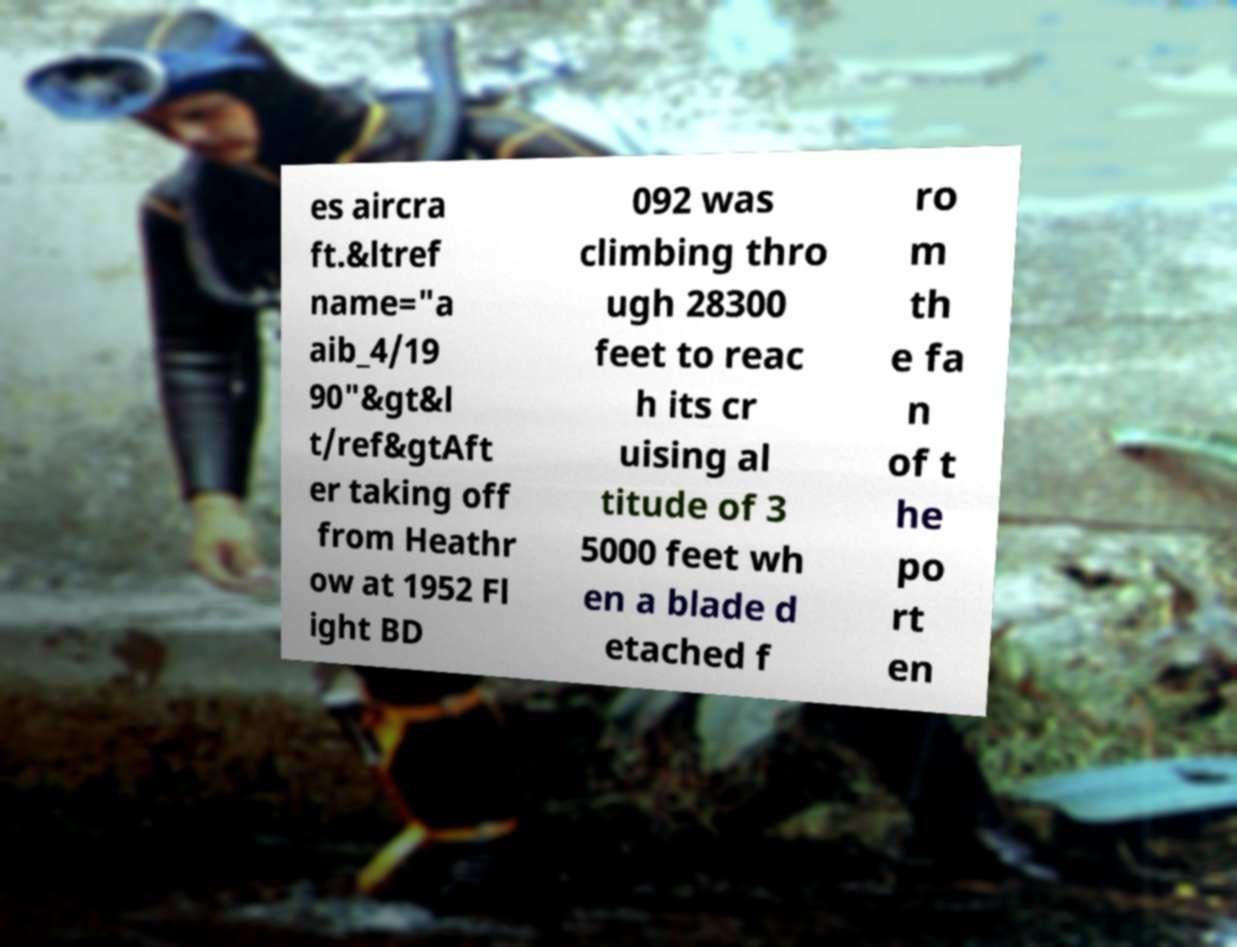I need the written content from this picture converted into text. Can you do that? es aircra ft.&ltref name="a aib_4/19 90"&gt&l t/ref&gtAft er taking off from Heathr ow at 1952 Fl ight BD 092 was climbing thro ugh 28300 feet to reac h its cr uising al titude of 3 5000 feet wh en a blade d etached f ro m th e fa n of t he po rt en 